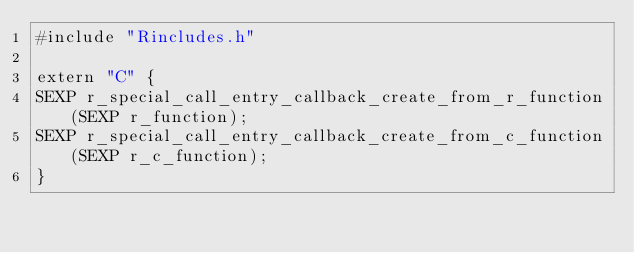<code> <loc_0><loc_0><loc_500><loc_500><_C_>#include "Rincludes.h"

extern "C" {
SEXP r_special_call_entry_callback_create_from_r_function(SEXP r_function);
SEXP r_special_call_entry_callback_create_from_c_function(SEXP r_c_function);
}
</code> 